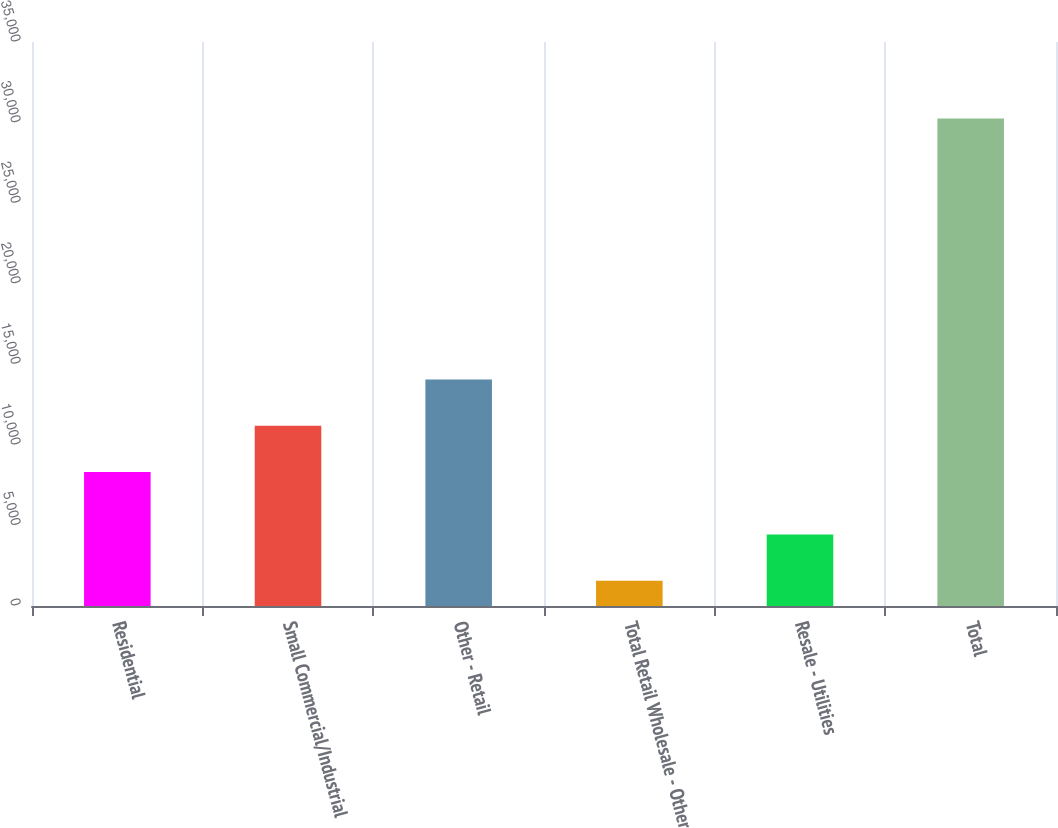Convert chart to OTSL. <chart><loc_0><loc_0><loc_500><loc_500><bar_chart><fcel>Residential<fcel>Small Commercial/Industrial<fcel>Other - Retail<fcel>Total Retail Wholesale - Other<fcel>Resale - Utilities<fcel>Total<nl><fcel>8317.7<fcel>11186.3<fcel>14054.8<fcel>1566.6<fcel>4435.16<fcel>30252.2<nl></chart> 